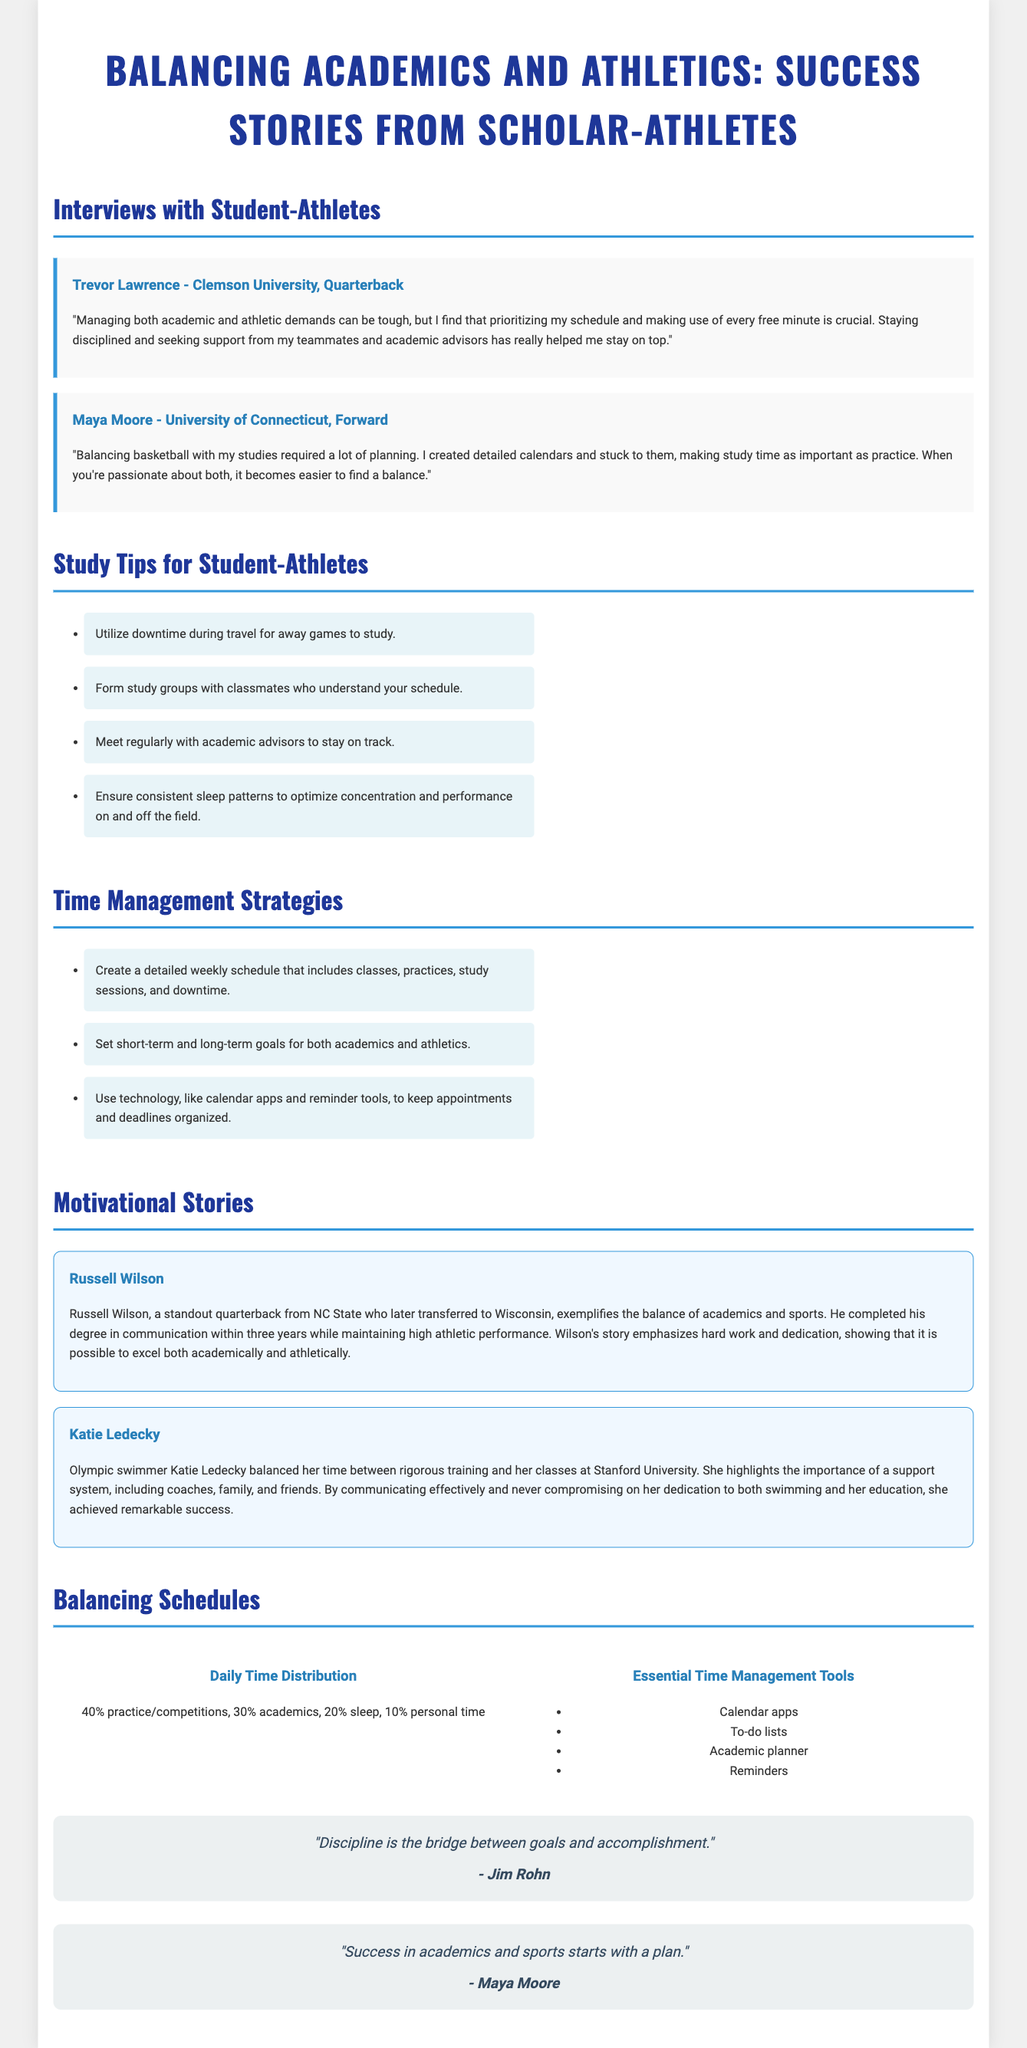What is the title of the document? The title is stated at the top of the document.
Answer: Balancing Academics and Athletics: Success Stories from Scholar-Athletes Who is featured as a quarterback in the interviews? The interviews section highlights specific individuals, including Trevor Lawrence.
Answer: Trevor Lawrence What study tip involves making use of travel time? The study tips list includes various strategies, one of which mentions travel.
Answer: Utilize downtime during travel for away games to study How long did Russell Wilson take to complete his degree? The motivational stories section provides details about Russell Wilson's education completion time.
Answer: three years What percentage of time is allocated for personal time in the infographic? The infographic illustrates the distribution of time in a student's day, including personal time.
Answer: 10% What does Maya Moore emphasize as a key to success? Maya Moore's quote in the document highlights an essential aspect of balancing academics and athletics.
Answer: a plan Which motivational speaker's quote is included in the document? The document includes quotes from various individuals; one is by Jim Rohn.
Answer: Jim Rohn What does Katie Ledecky highlight as important for balancing training and academics? Katie Ledecky's story outlines the significance of support systems for balance.
Answer: support system What is shown as 30% in the daily time distribution infographic? The infographic provides a breakdown of time distribution amongst various activities.
Answer: academics 